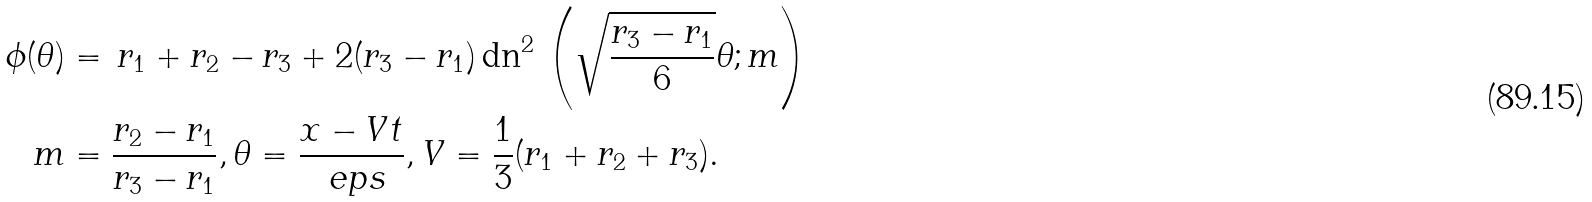Convert formula to latex. <formula><loc_0><loc_0><loc_500><loc_500>\phi ( \theta ) & = \, r _ { 1 } + r _ { 2 } - r _ { 3 } + 2 ( r _ { 3 } - r _ { 1 } ) \, \text {dn} ^ { 2 } \, \left ( \sqrt { \frac { r _ { 3 } - r _ { 1 } } { 6 } } \theta ; m \right ) \\ m & = \frac { r _ { 2 } - r _ { 1 } } { r _ { 3 } - r _ { 1 } } , \theta = \frac { x - V t } { \ e p s } , V = \frac { 1 } { 3 } ( r _ { 1 } + r _ { 2 } + r _ { 3 } ) .</formula> 